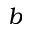Convert formula to latex. <formula><loc_0><loc_0><loc_500><loc_500>b</formula> 